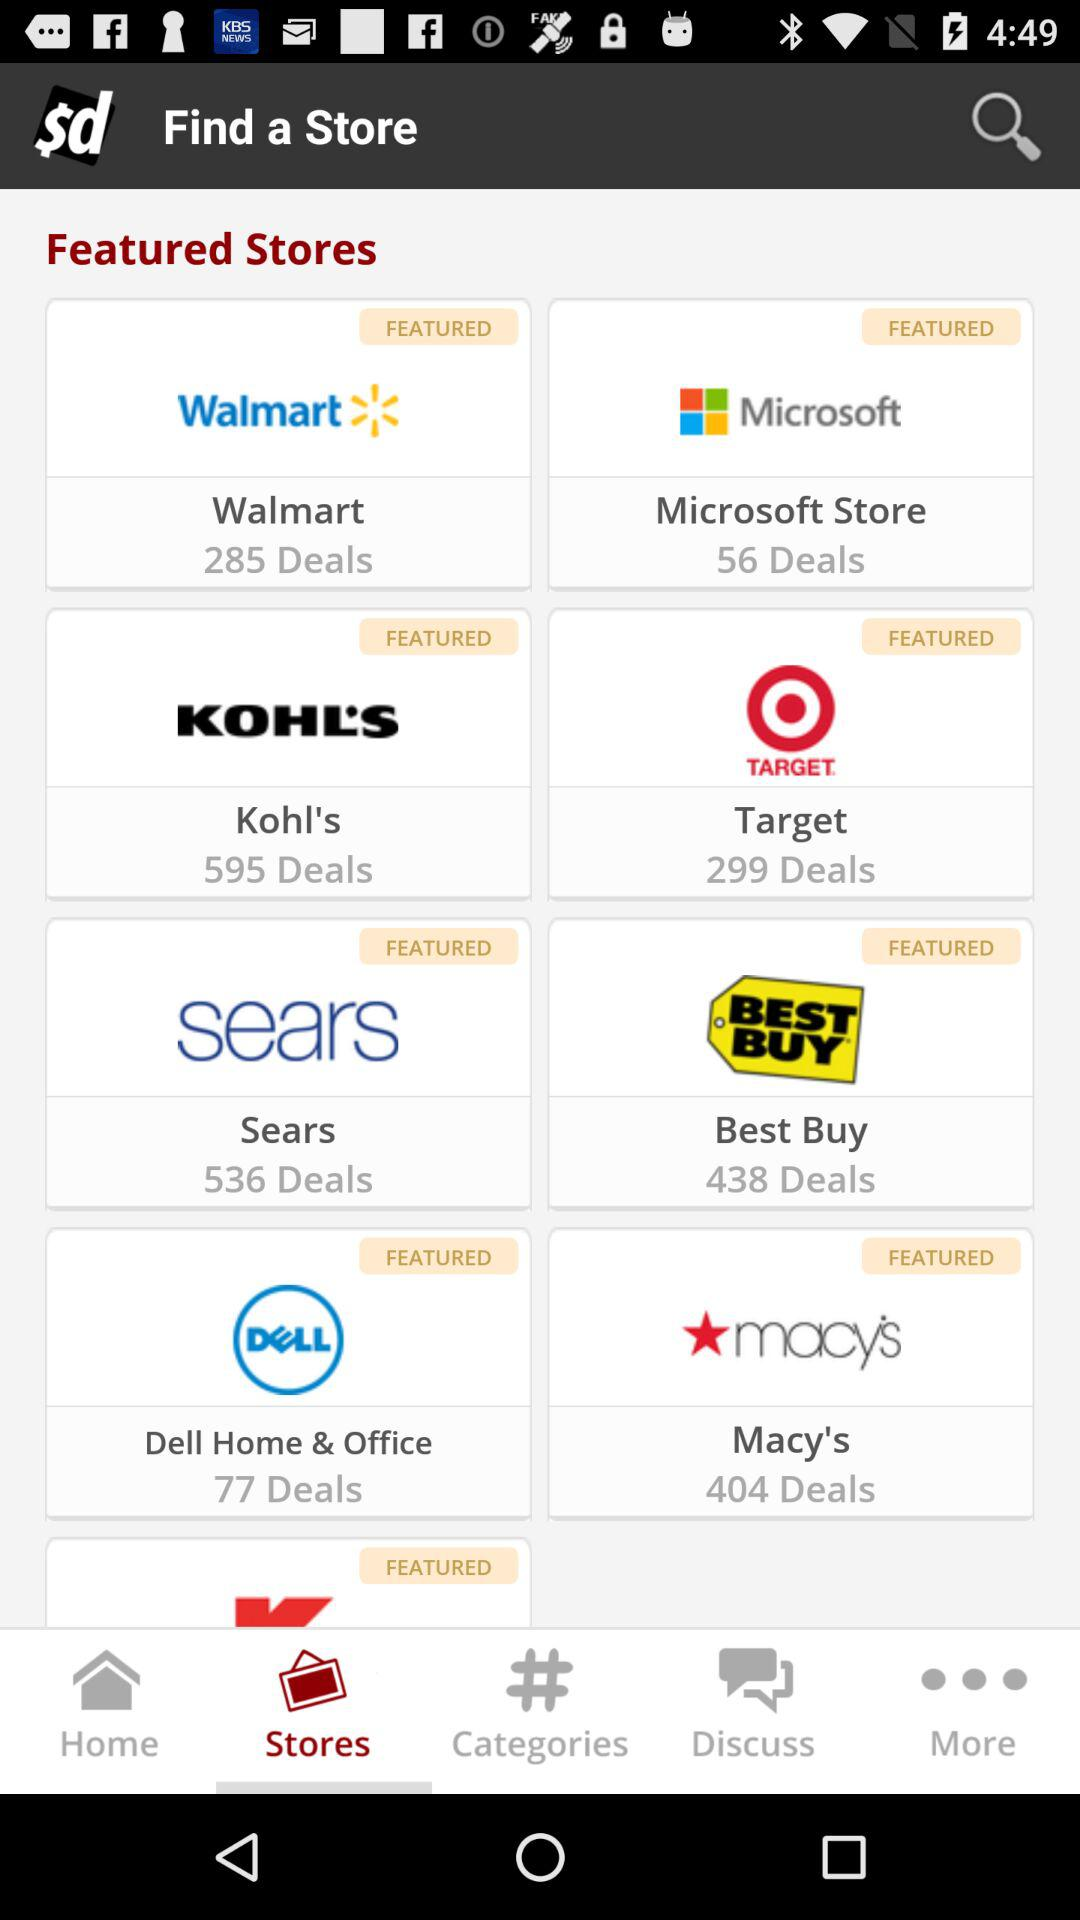How many deals are there for Walmart? There are 285 deals for Walmart. 